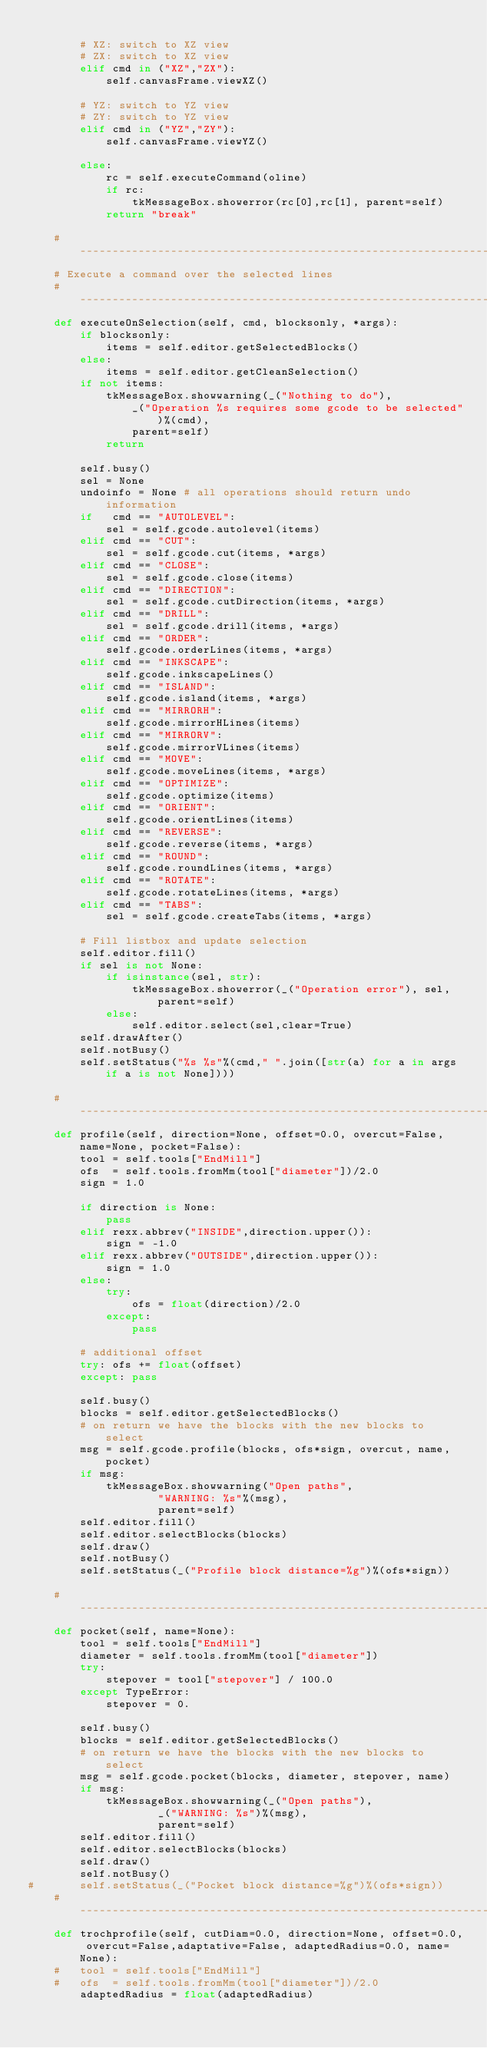<code> <loc_0><loc_0><loc_500><loc_500><_Python_>
		# XZ: switch to XZ view
		# ZX: switch to XZ view
		elif cmd in ("XZ","ZX"):
			self.canvasFrame.viewXZ()

		# YZ: switch to YZ view
		# ZY: switch to YZ view
		elif cmd in ("YZ","ZY"):
			self.canvasFrame.viewYZ()

		else:
			rc = self.executeCommand(oline)
			if rc:
				tkMessageBox.showerror(rc[0],rc[1], parent=self)
			return "break"

	#-----------------------------------------------------------------------
	# Execute a command over the selected lines
	#-----------------------------------------------------------------------
	def executeOnSelection(self, cmd, blocksonly, *args):
		if blocksonly:
			items = self.editor.getSelectedBlocks()
		else:
			items = self.editor.getCleanSelection()
		if not items:
			tkMessageBox.showwarning(_("Nothing to do"),
				_("Operation %s requires some gcode to be selected")%(cmd),
				parent=self)
			return

		self.busy()
		sel = None
		undoinfo = None	# all operations should return undo information
		if   cmd == "AUTOLEVEL":
			sel = self.gcode.autolevel(items)
		elif cmd == "CUT":
			sel = self.gcode.cut(items, *args)
		elif cmd == "CLOSE":
			sel = self.gcode.close(items)
		elif cmd == "DIRECTION":
			sel = self.gcode.cutDirection(items, *args)
		elif cmd == "DRILL":
			sel = self.gcode.drill(items, *args)
		elif cmd == "ORDER":
			self.gcode.orderLines(items, *args)
		elif cmd == "INKSCAPE":
			self.gcode.inkscapeLines()
		elif cmd == "ISLAND":
			self.gcode.island(items, *args)
		elif cmd == "MIRRORH":
			self.gcode.mirrorHLines(items)
		elif cmd == "MIRRORV":
			self.gcode.mirrorVLines(items)
		elif cmd == "MOVE":
			self.gcode.moveLines(items, *args)
		elif cmd == "OPTIMIZE":
			self.gcode.optimize(items)
		elif cmd == "ORIENT":
			self.gcode.orientLines(items)
		elif cmd == "REVERSE":
			self.gcode.reverse(items, *args)
		elif cmd == "ROUND":
			self.gcode.roundLines(items, *args)
		elif cmd == "ROTATE":
			self.gcode.rotateLines(items, *args)
		elif cmd == "TABS":
			sel = self.gcode.createTabs(items, *args)

		# Fill listbox and update selection
		self.editor.fill()
		if sel is not None:
			if isinstance(sel, str):
				tkMessageBox.showerror(_("Operation error"), sel, parent=self)
			else:
				self.editor.select(sel,clear=True)
		self.drawAfter()
		self.notBusy()
		self.setStatus("%s %s"%(cmd," ".join([str(a) for a in args if a is not None])))

	#-----------------------------------------------------------------------
	def profile(self, direction=None, offset=0.0, overcut=False, name=None, pocket=False):
		tool = self.tools["EndMill"]
		ofs  = self.tools.fromMm(tool["diameter"])/2.0
		sign = 1.0

		if direction is None:
			pass
		elif rexx.abbrev("INSIDE",direction.upper()):
			sign = -1.0
		elif rexx.abbrev("OUTSIDE",direction.upper()):
			sign = 1.0
		else:
			try:
				ofs = float(direction)/2.0
			except:
				pass

		# additional offset
		try: ofs += float(offset)
		except: pass

		self.busy()
		blocks = self.editor.getSelectedBlocks()
		# on return we have the blocks with the new blocks to select
		msg = self.gcode.profile(blocks, ofs*sign, overcut, name, pocket)
		if msg:
			tkMessageBox.showwarning("Open paths",
					"WARNING: %s"%(msg),
					parent=self)
		self.editor.fill()
		self.editor.selectBlocks(blocks)
		self.draw()
		self.notBusy()
		self.setStatus(_("Profile block distance=%g")%(ofs*sign))

	#-----------------------------------------------------------------------
	def pocket(self, name=None):
		tool = self.tools["EndMill"]
		diameter = self.tools.fromMm(tool["diameter"])
		try:
			stepover = tool["stepover"] / 100.0
		except TypeError:
			stepover = 0.

		self.busy()
		blocks = self.editor.getSelectedBlocks()
		# on return we have the blocks with the new blocks to select
		msg = self.gcode.pocket(blocks, diameter, stepover, name)
		if msg:
			tkMessageBox.showwarning(_("Open paths"),
					_("WARNING: %s")%(msg),
					parent=self)
		self.editor.fill()
		self.editor.selectBlocks(blocks)
		self.draw()
		self.notBusy()
#		self.setStatus(_("Pocket block distance=%g")%(ofs*sign))
	#-----------------------------------------------------------------------
	def trochprofile(self, cutDiam=0.0, direction=None, offset=0.0, overcut=False,adaptative=False, adaptedRadius=0.0, name=None):
	#	tool = self.tools["EndMill"]
	#	ofs  = self.tools.fromMm(tool["diameter"])/2.0
		adaptedRadius = float(adaptedRadius)</code> 